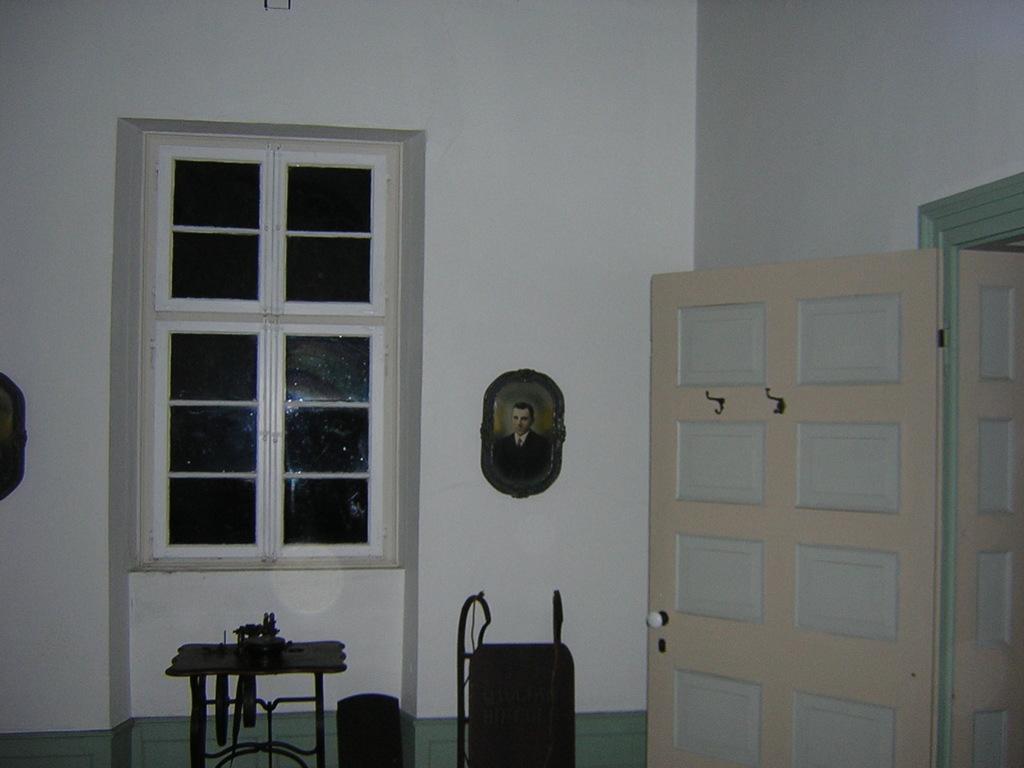How would you summarize this image in a sentence or two? In this image there are doors and windows with a photo frame on the wall, in front of the photo frame there is a table with few objects on top of it. 